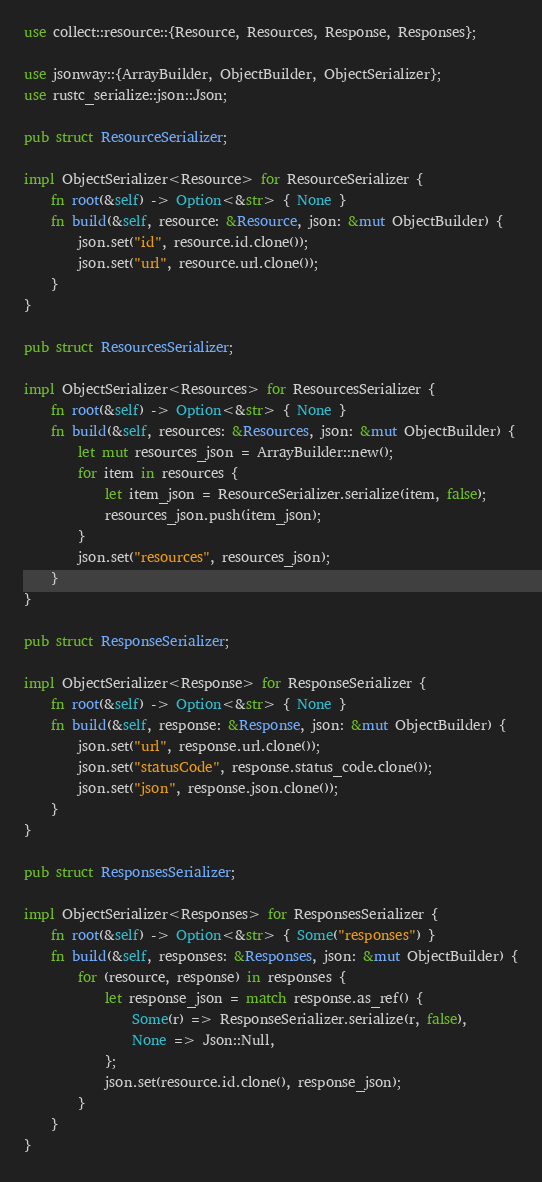Convert code to text. <code><loc_0><loc_0><loc_500><loc_500><_Rust_>use collect::resource::{Resource, Resources, Response, Responses};

use jsonway::{ArrayBuilder, ObjectBuilder, ObjectSerializer};
use rustc_serialize::json::Json;

pub struct ResourceSerializer;

impl ObjectSerializer<Resource> for ResourceSerializer {
    fn root(&self) -> Option<&str> { None }
    fn build(&self, resource: &Resource, json: &mut ObjectBuilder) {
        json.set("id", resource.id.clone());
        json.set("url", resource.url.clone());
    }
}

pub struct ResourcesSerializer;

impl ObjectSerializer<Resources> for ResourcesSerializer {
    fn root(&self) -> Option<&str> { None }
    fn build(&self, resources: &Resources, json: &mut ObjectBuilder) {
        let mut resources_json = ArrayBuilder::new();
        for item in resources {
            let item_json = ResourceSerializer.serialize(item, false);
            resources_json.push(item_json);
        }
        json.set("resources", resources_json);
    }
}

pub struct ResponseSerializer;

impl ObjectSerializer<Response> for ResponseSerializer {
    fn root(&self) -> Option<&str> { None }
    fn build(&self, response: &Response, json: &mut ObjectBuilder) {
        json.set("url", response.url.clone());
        json.set("statusCode", response.status_code.clone());
        json.set("json", response.json.clone());
    }
}

pub struct ResponsesSerializer;

impl ObjectSerializer<Responses> for ResponsesSerializer {
    fn root(&self) -> Option<&str> { Some("responses") }
    fn build(&self, responses: &Responses, json: &mut ObjectBuilder) {
        for (resource, response) in responses {
            let response_json = match response.as_ref() {
                Some(r) => ResponseSerializer.serialize(r, false),
                None => Json::Null,
            };
            json.set(resource.id.clone(), response_json);
        }
    }
}
</code> 